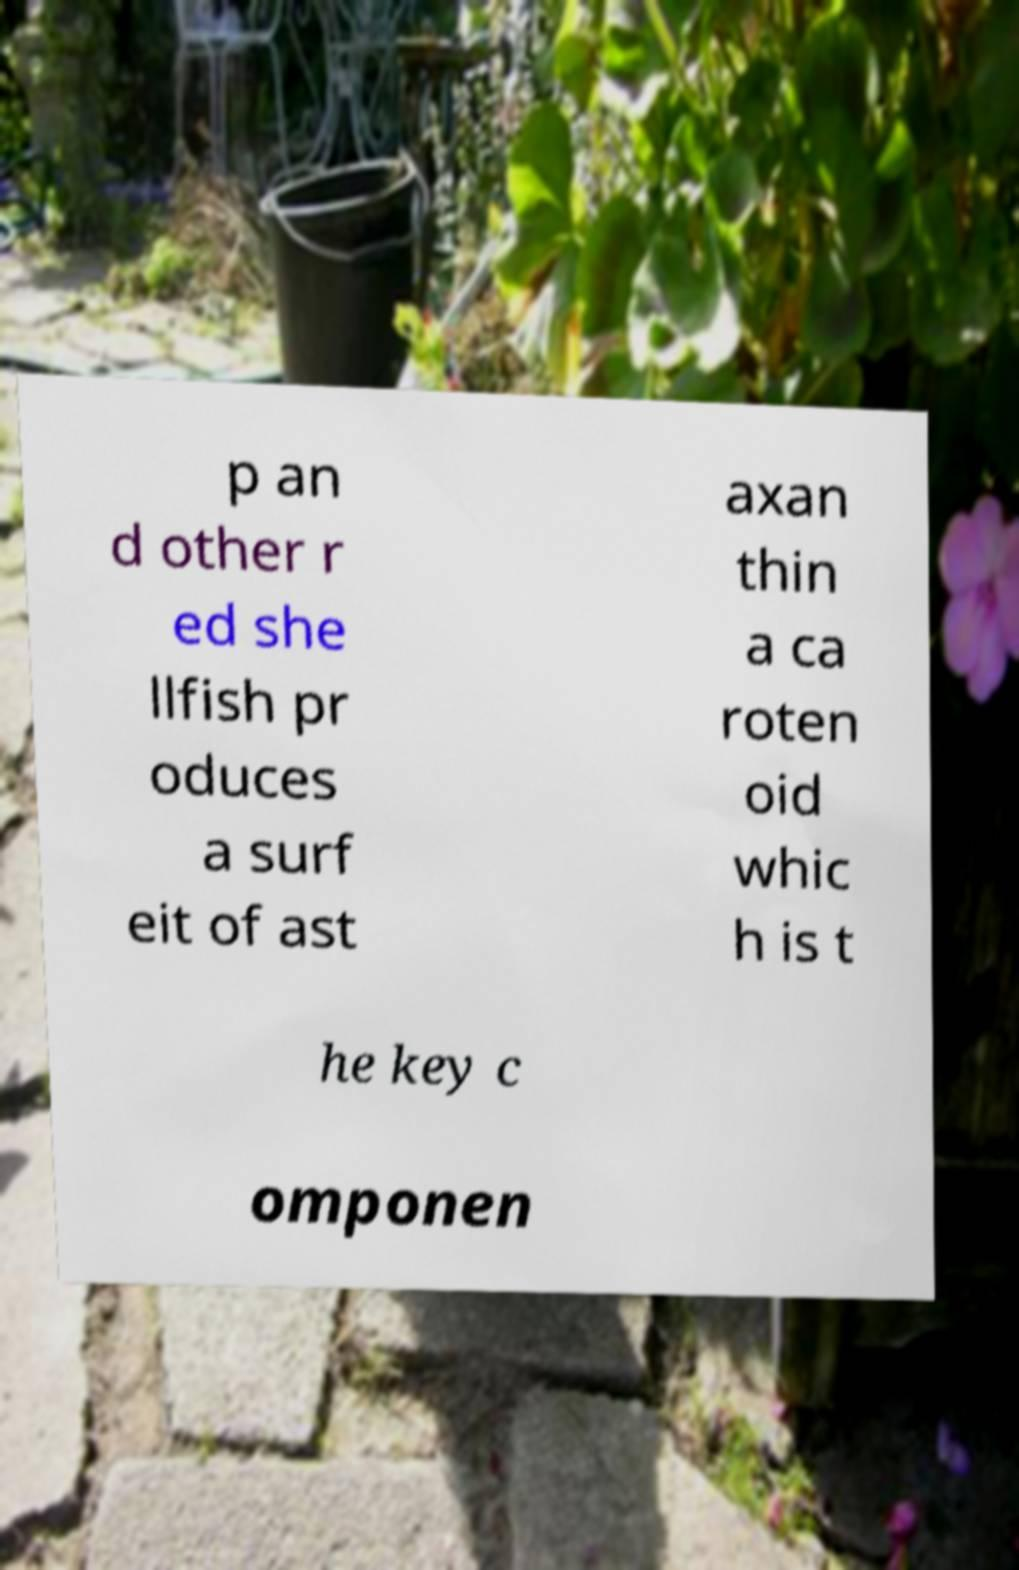For documentation purposes, I need the text within this image transcribed. Could you provide that? p an d other r ed she llfish pr oduces a surf eit of ast axan thin a ca roten oid whic h is t he key c omponen 